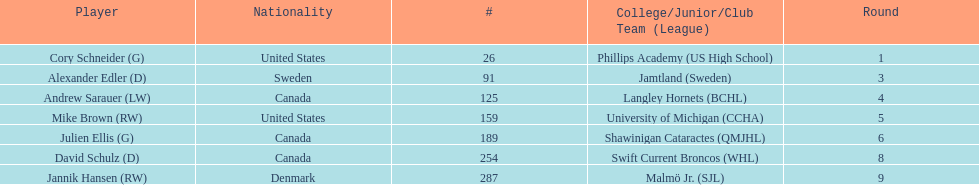Write the full table. {'header': ['Player', 'Nationality', '#', 'College/Junior/Club Team (League)', 'Round'], 'rows': [['Cory Schneider (G)', 'United States', '26', 'Phillips Academy (US High School)', '1'], ['Alexander Edler (D)', 'Sweden', '91', 'Jamtland (Sweden)', '3'], ['Andrew Sarauer (LW)', 'Canada', '125', 'Langley Hornets (BCHL)', '4'], ['Mike Brown (RW)', 'United States', '159', 'University of Michigan (CCHA)', '5'], ['Julien Ellis (G)', 'Canada', '189', 'Shawinigan Cataractes (QMJHL)', '6'], ['David Schulz (D)', 'Canada', '254', 'Swift Current Broncos (WHL)', '8'], ['Jannik Hansen (RW)', 'Denmark', '287', 'Malmö Jr. (SJL)', '9']]} How many players are from the united states? 2. 